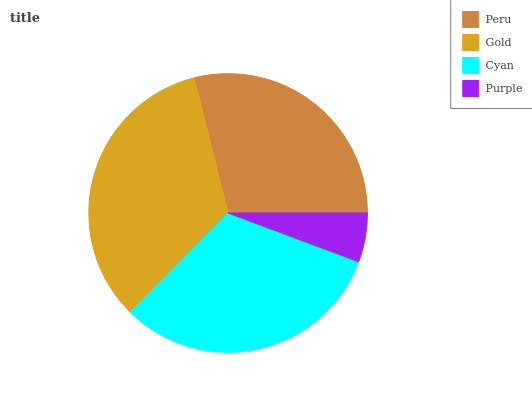Is Purple the minimum?
Answer yes or no. Yes. Is Gold the maximum?
Answer yes or no. Yes. Is Cyan the minimum?
Answer yes or no. No. Is Cyan the maximum?
Answer yes or no. No. Is Gold greater than Cyan?
Answer yes or no. Yes. Is Cyan less than Gold?
Answer yes or no. Yes. Is Cyan greater than Gold?
Answer yes or no. No. Is Gold less than Cyan?
Answer yes or no. No. Is Cyan the high median?
Answer yes or no. Yes. Is Peru the low median?
Answer yes or no. Yes. Is Peru the high median?
Answer yes or no. No. Is Gold the low median?
Answer yes or no. No. 